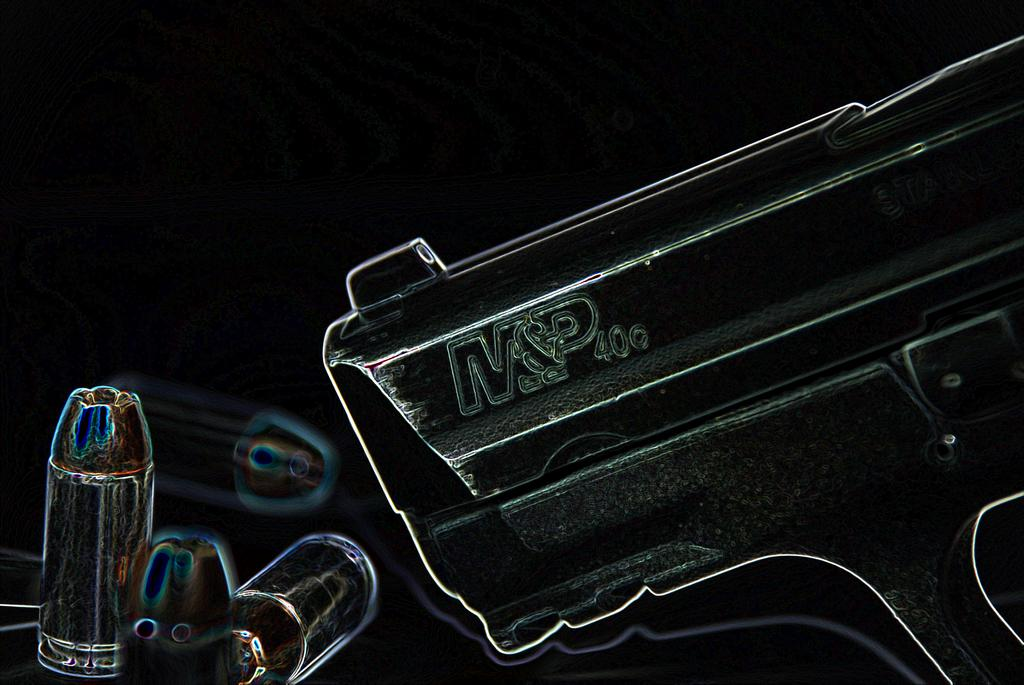What is the overall color scheme of the image? The background of the image is dark. What can be seen on the right side of the image? There is a gun on the right side of the image. What is present on the left side of the image? There are a few bullets on the left side of the image. What type of beast is present in the image? There is no beast present in the image; it only features a gun and bullets. How does the society depicted in the image function? The image does not depict a society, so it is not possible to determine how it functions. 